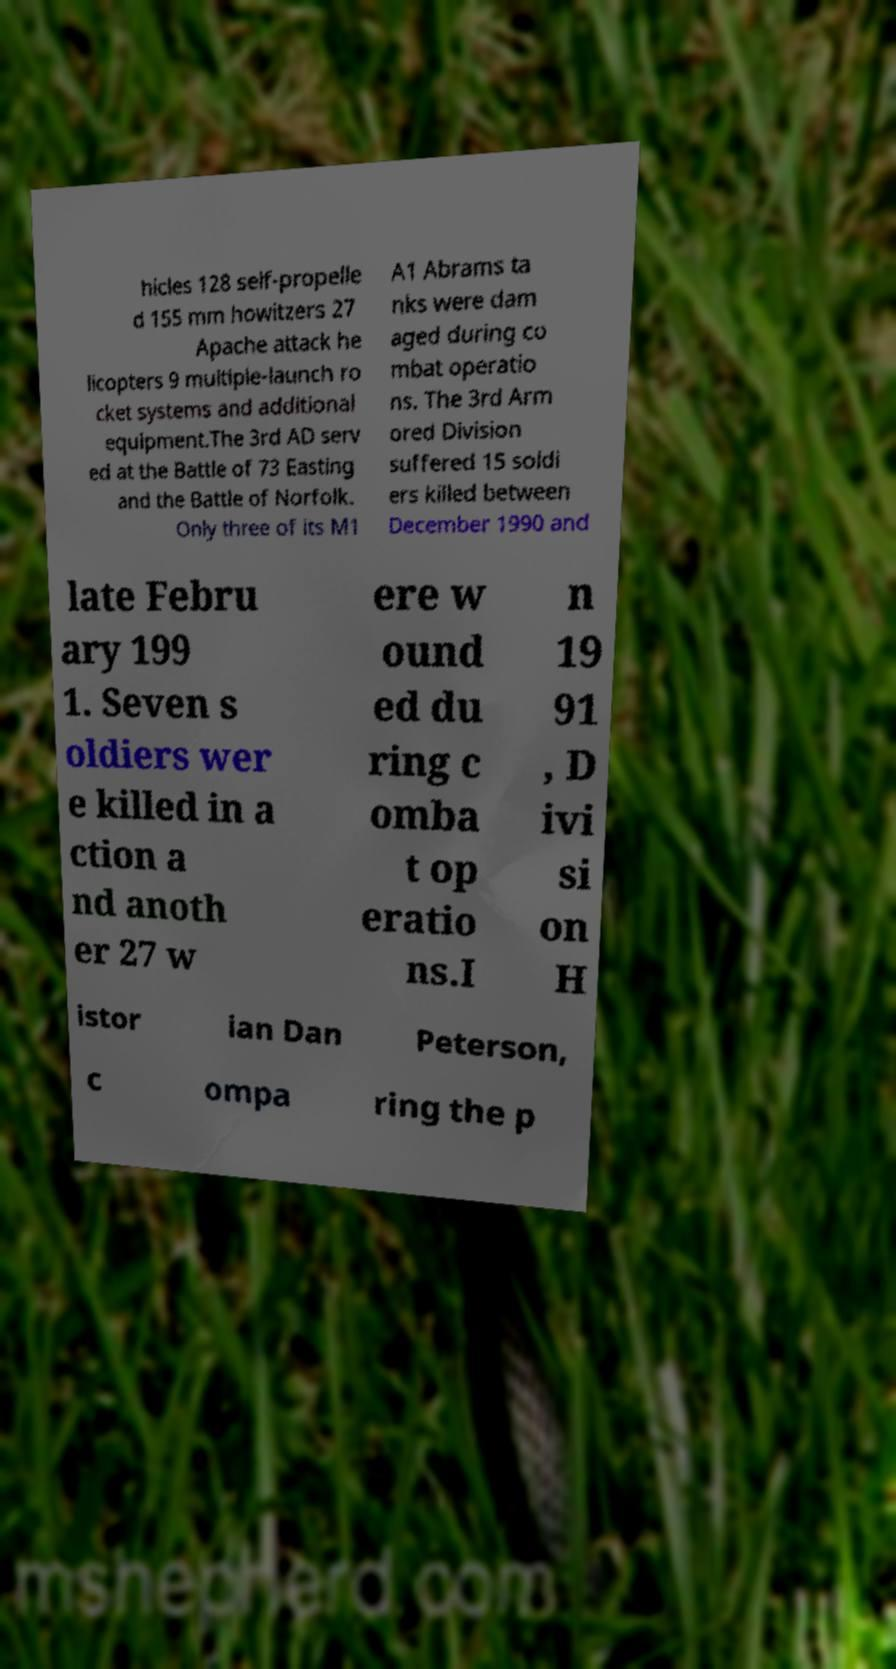Please read and relay the text visible in this image. What does it say? hicles 128 self-propelle d 155 mm howitzers 27 Apache attack he licopters 9 multiple-launch ro cket systems and additional equipment.The 3rd AD serv ed at the Battle of 73 Easting and the Battle of Norfolk. Only three of its M1 A1 Abrams ta nks were dam aged during co mbat operatio ns. The 3rd Arm ored Division suffered 15 soldi ers killed between December 1990 and late Febru ary 199 1. Seven s oldiers wer e killed in a ction a nd anoth er 27 w ere w ound ed du ring c omba t op eratio ns.I n 19 91 , D ivi si on H istor ian Dan Peterson, c ompa ring the p 